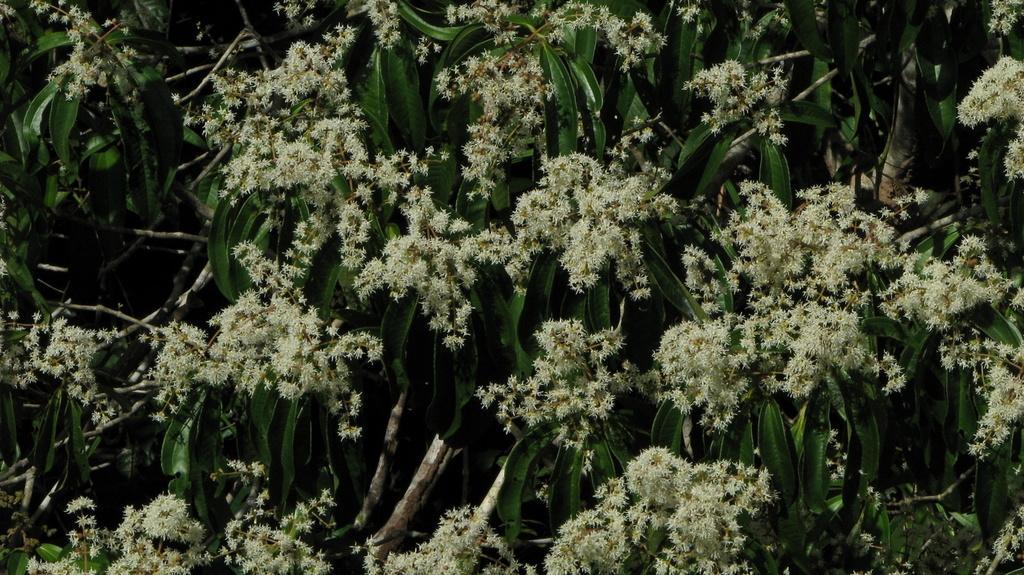Can you describe this image briefly? In this image I can see few trees which are green in color and to it I can see few flowers which are cream in color. 